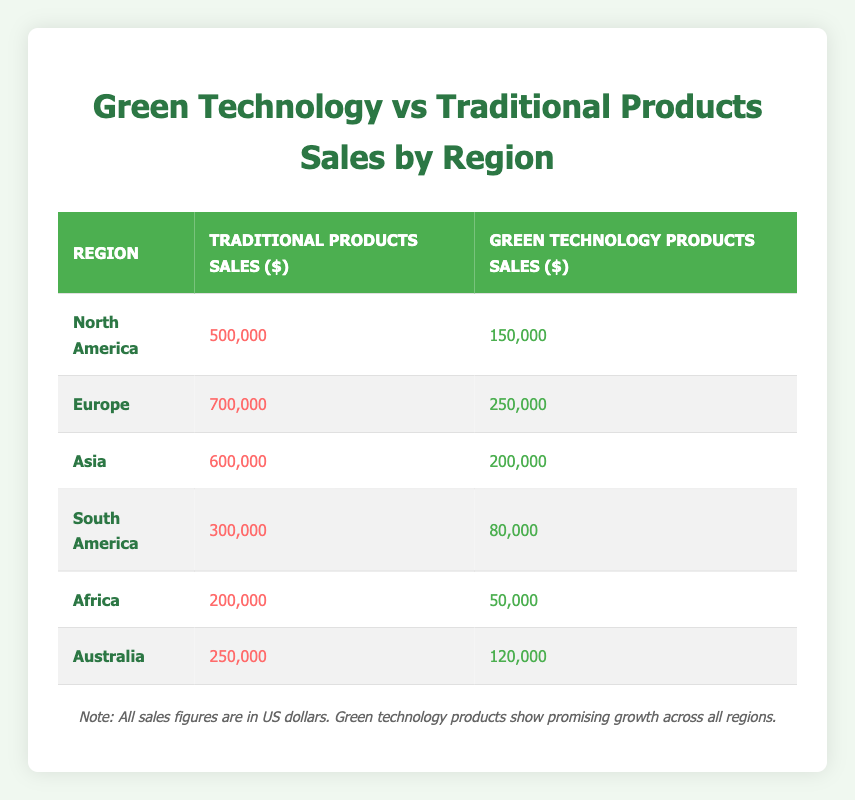What is the total sales of traditional products in North America? In the table, under the North America row, the sales figure for traditional products is listed as 500,000.
Answer: 500,000 What is the sales figure for green technology products in Europe? In the table, under the Europe row, the sales figure for green technology products is given as 250,000.
Answer: 250,000 Which region has the highest sales of green technology products? By comparing the green technology products sales across all regions, Europe has the highest sales at 250,000, more than any other region.
Answer: Europe What is the combined total sales of green technology products for all regions? To find the combined total sales for green technology products, we sum the sales figures: 150,000 (North America) + 250,000 (Europe) + 200,000 (Asia) + 80,000 (South America) + 50,000 (Africa) + 120,000 (Australia) = 850,000.
Answer: 850,000 Is the sales figure for traditional products in Asia greater than that in South America? The sales figure for traditional products in Asia is 600,000, which is greater than 300,000 in South America, making the statement true.
Answer: Yes What is the average sales figure for traditional products across all regions? The average can be calculated by summing the traditional products sales for all regions: (500,000 + 700,000 + 600,000 + 300,000 + 200,000 + 250,000) = 2,550,000. There are six regions, so the average is 2,550,000 / 6 = 425,000.
Answer: 425,000 Is it true that Africa's sales for green technology products are equal to Australia’s? The sales figure for Africa’s green technology products is 50,000, while for Australia, it is 120,000, meaning they are not equal.
Answer: No Which region's traditional product sales exceed green technology sales by the largest amount? By calculating the difference between traditional and green technology sales for each region: North America (350,000), Europe (450,000), Asia (400,000), South America (220,000), Africa (150,000), and Australia (130,000), we find that Europe has the largest difference of 450,000.
Answer: Europe What percentage of total sales in North America comes from green technology products? In North America, the total sales are 500,000 (traditional) + 150,000 (green) = 650,000. The percentage of green technology sales is (150,000 / 650,000) * 100 = approximately 23.08%.
Answer: 23.08% 